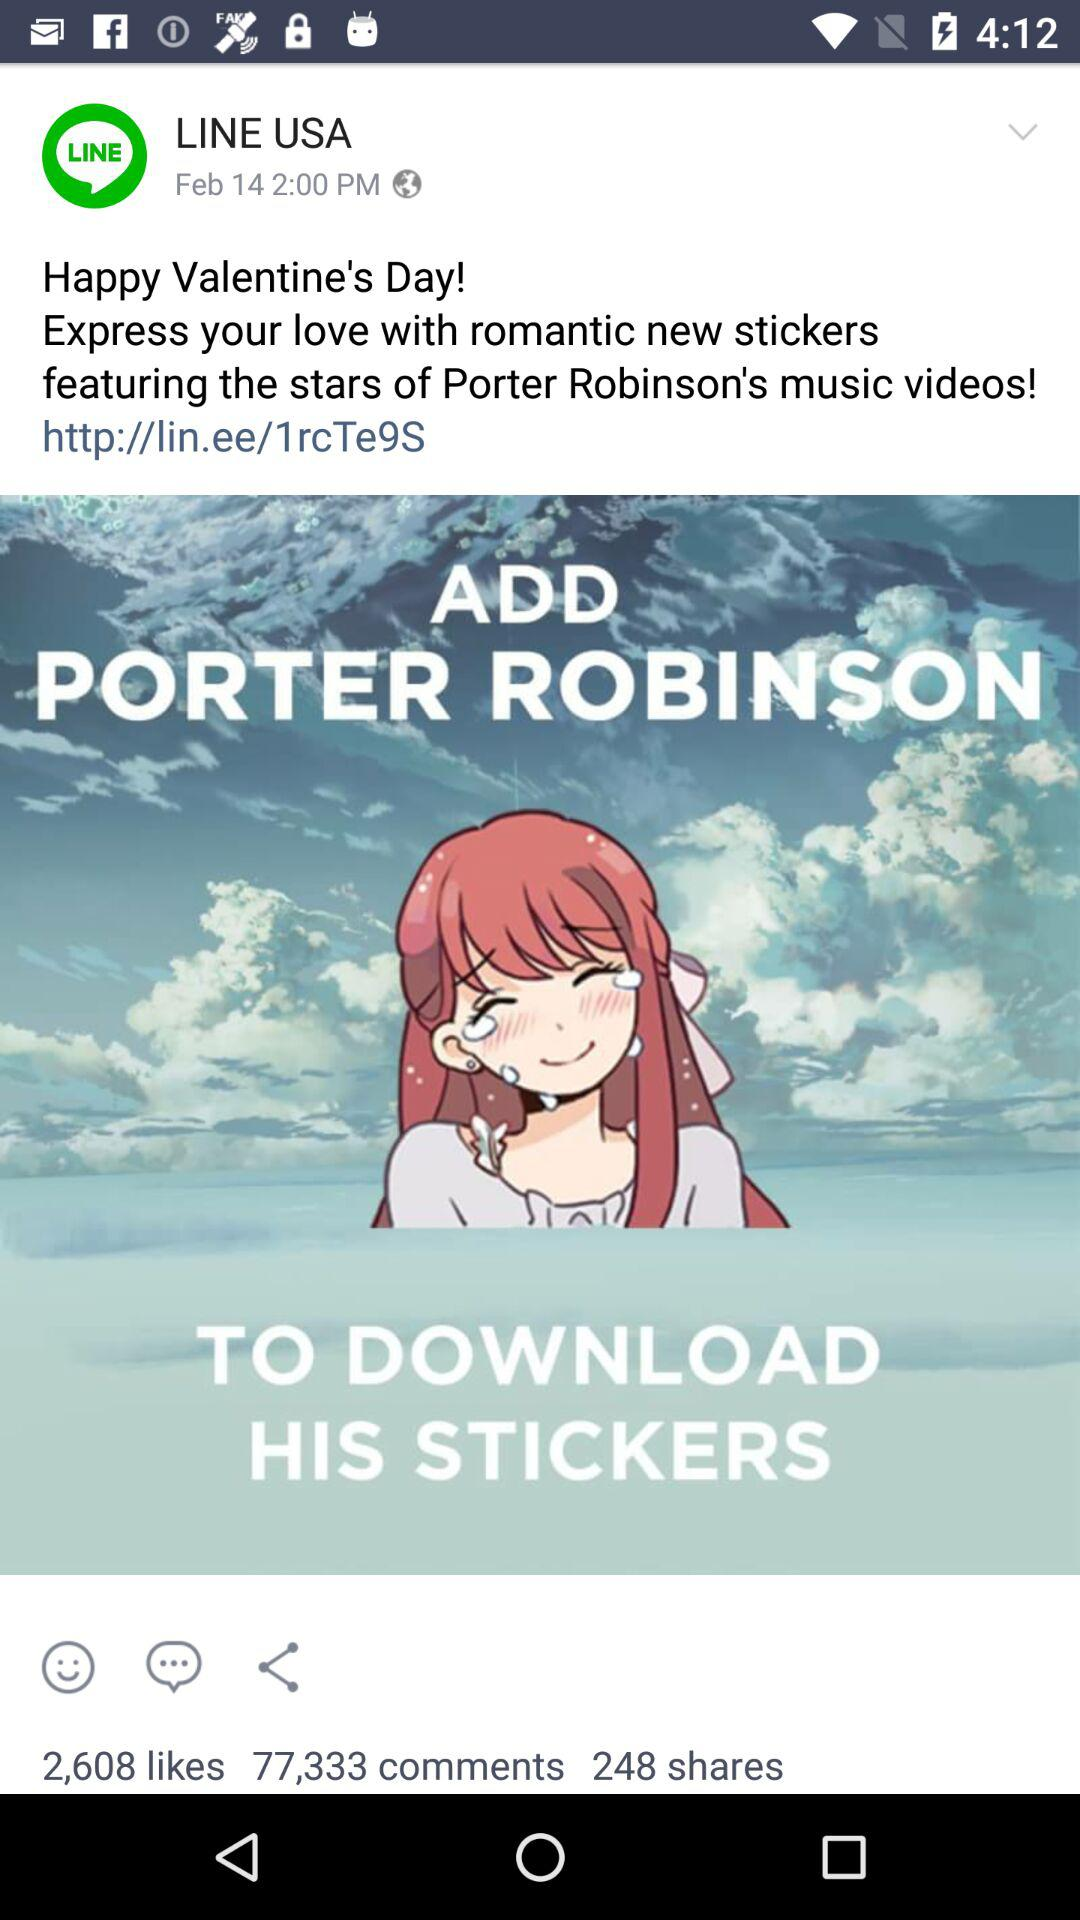How many likes did the sticker post get? There are 2,608 likes. 